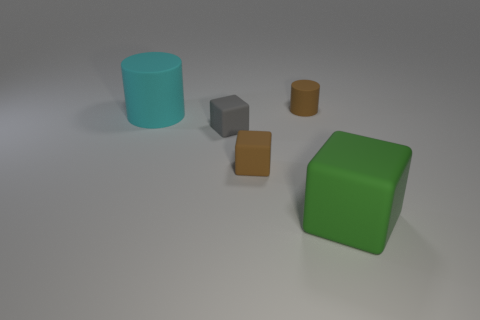Add 4 big gray shiny things. How many objects exist? 9 Subtract all blocks. How many objects are left? 2 Add 1 large green rubber objects. How many large green rubber objects are left? 2 Add 2 cyan blocks. How many cyan blocks exist? 2 Subtract 0 cyan blocks. How many objects are left? 5 Subtract all cylinders. Subtract all gray matte things. How many objects are left? 2 